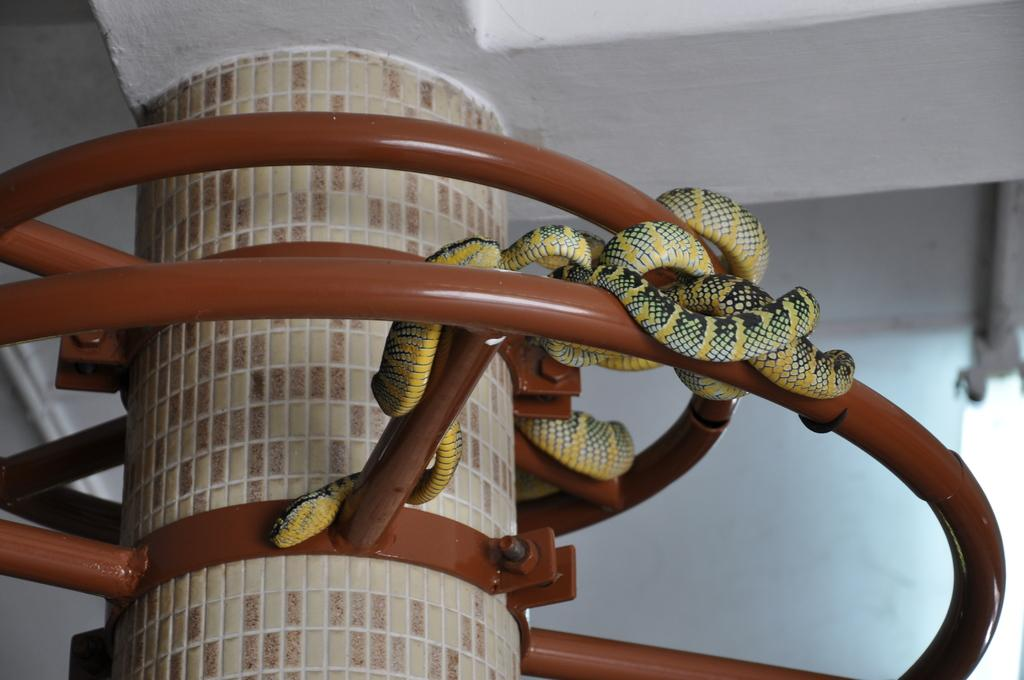What type of architectural element is visible in the picture? There is a pillar of a building in the picture. What material is the structure block made of? The structure block is made of metal. What creatures are on the metal structure block? There are snakes on the metal structure block. What time does the alarm go off in the image? There is no alarm present in the image. Can you see any veins in the snakes in the image? The image does not show the snakes' internal anatomy, so it is not possible to determine if their veins are visible. 